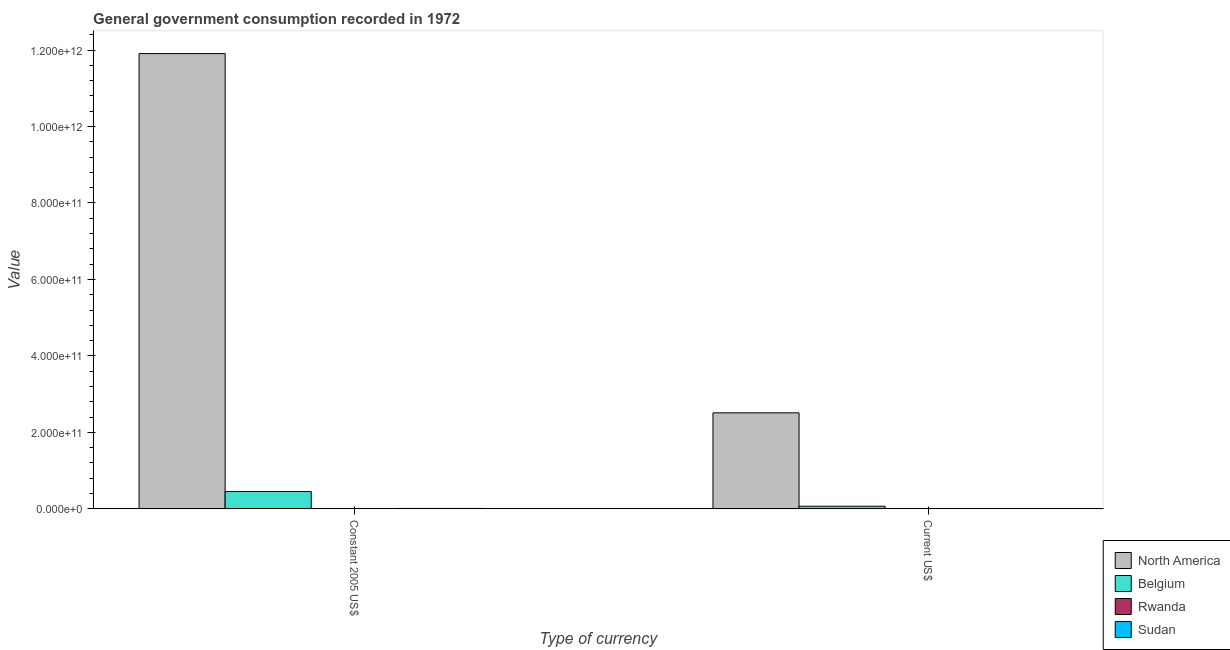How many different coloured bars are there?
Make the answer very short. 4. How many groups of bars are there?
Provide a short and direct response. 2. Are the number of bars per tick equal to the number of legend labels?
Keep it short and to the point. Yes. How many bars are there on the 1st tick from the left?
Ensure brevity in your answer.  4. What is the label of the 1st group of bars from the left?
Offer a terse response. Constant 2005 US$. What is the value consumed in constant 2005 us$ in Belgium?
Provide a succinct answer. 4.53e+1. Across all countries, what is the maximum value consumed in current us$?
Your response must be concise. 2.51e+11. Across all countries, what is the minimum value consumed in current us$?
Your response must be concise. 2.64e+07. In which country was the value consumed in current us$ minimum?
Provide a short and direct response. Rwanda. What is the total value consumed in constant 2005 us$ in the graph?
Keep it short and to the point. 1.24e+12. What is the difference between the value consumed in current us$ in Rwanda and that in Belgium?
Provide a succinct answer. -6.76e+09. What is the difference between the value consumed in constant 2005 us$ in North America and the value consumed in current us$ in Rwanda?
Make the answer very short. 1.19e+12. What is the average value consumed in current us$ per country?
Your response must be concise. 6.46e+1. What is the difference between the value consumed in constant 2005 us$ and value consumed in current us$ in Rwanda?
Make the answer very short. 5.56e+07. In how many countries, is the value consumed in current us$ greater than 760000000000 ?
Give a very brief answer. 0. What is the ratio of the value consumed in current us$ in Sudan to that in North America?
Offer a very short reply. 0. In how many countries, is the value consumed in constant 2005 us$ greater than the average value consumed in constant 2005 us$ taken over all countries?
Offer a very short reply. 1. What does the 3rd bar from the left in Constant 2005 US$ represents?
Make the answer very short. Rwanda. What does the 4th bar from the right in Current US$ represents?
Provide a short and direct response. North America. How many bars are there?
Ensure brevity in your answer.  8. What is the difference between two consecutive major ticks on the Y-axis?
Provide a succinct answer. 2.00e+11. Are the values on the major ticks of Y-axis written in scientific E-notation?
Give a very brief answer. Yes. Does the graph contain grids?
Ensure brevity in your answer.  No. How many legend labels are there?
Provide a short and direct response. 4. What is the title of the graph?
Provide a short and direct response. General government consumption recorded in 1972. Does "St. Martin (French part)" appear as one of the legend labels in the graph?
Your answer should be compact. No. What is the label or title of the X-axis?
Provide a short and direct response. Type of currency. What is the label or title of the Y-axis?
Ensure brevity in your answer.  Value. What is the Value of North America in Constant 2005 US$?
Give a very brief answer. 1.19e+12. What is the Value in Belgium in Constant 2005 US$?
Ensure brevity in your answer.  4.53e+1. What is the Value in Rwanda in Constant 2005 US$?
Offer a terse response. 8.20e+07. What is the Value of Sudan in Constant 2005 US$?
Your response must be concise. 1.15e+09. What is the Value of North America in Current US$?
Make the answer very short. 2.51e+11. What is the Value in Belgium in Current US$?
Ensure brevity in your answer.  6.79e+09. What is the Value of Rwanda in Current US$?
Offer a very short reply. 2.64e+07. What is the Value in Sudan in Current US$?
Make the answer very short. 4.48e+08. Across all Type of currency, what is the maximum Value in North America?
Your answer should be very brief. 1.19e+12. Across all Type of currency, what is the maximum Value in Belgium?
Keep it short and to the point. 4.53e+1. Across all Type of currency, what is the maximum Value in Rwanda?
Keep it short and to the point. 8.20e+07. Across all Type of currency, what is the maximum Value of Sudan?
Your answer should be very brief. 1.15e+09. Across all Type of currency, what is the minimum Value in North America?
Give a very brief answer. 2.51e+11. Across all Type of currency, what is the minimum Value of Belgium?
Your response must be concise. 6.79e+09. Across all Type of currency, what is the minimum Value in Rwanda?
Offer a very short reply. 2.64e+07. Across all Type of currency, what is the minimum Value in Sudan?
Offer a terse response. 4.48e+08. What is the total Value of North America in the graph?
Provide a short and direct response. 1.44e+12. What is the total Value of Belgium in the graph?
Your response must be concise. 5.21e+1. What is the total Value of Rwanda in the graph?
Ensure brevity in your answer.  1.08e+08. What is the total Value of Sudan in the graph?
Ensure brevity in your answer.  1.59e+09. What is the difference between the Value of North America in Constant 2005 US$ and that in Current US$?
Keep it short and to the point. 9.40e+11. What is the difference between the Value in Belgium in Constant 2005 US$ and that in Current US$?
Give a very brief answer. 3.85e+1. What is the difference between the Value in Rwanda in Constant 2005 US$ and that in Current US$?
Make the answer very short. 5.56e+07. What is the difference between the Value in Sudan in Constant 2005 US$ and that in Current US$?
Give a very brief answer. 6.98e+08. What is the difference between the Value of North America in Constant 2005 US$ and the Value of Belgium in Current US$?
Your answer should be very brief. 1.18e+12. What is the difference between the Value in North America in Constant 2005 US$ and the Value in Rwanda in Current US$?
Make the answer very short. 1.19e+12. What is the difference between the Value in North America in Constant 2005 US$ and the Value in Sudan in Current US$?
Make the answer very short. 1.19e+12. What is the difference between the Value in Belgium in Constant 2005 US$ and the Value in Rwanda in Current US$?
Ensure brevity in your answer.  4.53e+1. What is the difference between the Value of Belgium in Constant 2005 US$ and the Value of Sudan in Current US$?
Give a very brief answer. 4.49e+1. What is the difference between the Value of Rwanda in Constant 2005 US$ and the Value of Sudan in Current US$?
Offer a terse response. -3.66e+08. What is the average Value in North America per Type of currency?
Offer a very short reply. 7.21e+11. What is the average Value in Belgium per Type of currency?
Give a very brief answer. 2.60e+1. What is the average Value of Rwanda per Type of currency?
Provide a short and direct response. 5.42e+07. What is the average Value in Sudan per Type of currency?
Make the answer very short. 7.97e+08. What is the difference between the Value in North America and Value in Belgium in Constant 2005 US$?
Give a very brief answer. 1.15e+12. What is the difference between the Value of North America and Value of Rwanda in Constant 2005 US$?
Your answer should be compact. 1.19e+12. What is the difference between the Value in North America and Value in Sudan in Constant 2005 US$?
Make the answer very short. 1.19e+12. What is the difference between the Value in Belgium and Value in Rwanda in Constant 2005 US$?
Provide a succinct answer. 4.52e+1. What is the difference between the Value of Belgium and Value of Sudan in Constant 2005 US$?
Ensure brevity in your answer.  4.42e+1. What is the difference between the Value of Rwanda and Value of Sudan in Constant 2005 US$?
Offer a terse response. -1.06e+09. What is the difference between the Value in North America and Value in Belgium in Current US$?
Offer a terse response. 2.44e+11. What is the difference between the Value of North America and Value of Rwanda in Current US$?
Provide a succinct answer. 2.51e+11. What is the difference between the Value of North America and Value of Sudan in Current US$?
Make the answer very short. 2.51e+11. What is the difference between the Value of Belgium and Value of Rwanda in Current US$?
Offer a terse response. 6.76e+09. What is the difference between the Value of Belgium and Value of Sudan in Current US$?
Your answer should be compact. 6.34e+09. What is the difference between the Value in Rwanda and Value in Sudan in Current US$?
Make the answer very short. -4.21e+08. What is the ratio of the Value of North America in Constant 2005 US$ to that in Current US$?
Offer a very short reply. 4.74. What is the ratio of the Value of Belgium in Constant 2005 US$ to that in Current US$?
Offer a very short reply. 6.67. What is the ratio of the Value of Rwanda in Constant 2005 US$ to that in Current US$?
Keep it short and to the point. 3.11. What is the ratio of the Value of Sudan in Constant 2005 US$ to that in Current US$?
Your answer should be very brief. 2.56. What is the difference between the highest and the second highest Value of North America?
Offer a very short reply. 9.40e+11. What is the difference between the highest and the second highest Value in Belgium?
Your response must be concise. 3.85e+1. What is the difference between the highest and the second highest Value in Rwanda?
Ensure brevity in your answer.  5.56e+07. What is the difference between the highest and the second highest Value of Sudan?
Keep it short and to the point. 6.98e+08. What is the difference between the highest and the lowest Value of North America?
Your response must be concise. 9.40e+11. What is the difference between the highest and the lowest Value of Belgium?
Offer a very short reply. 3.85e+1. What is the difference between the highest and the lowest Value of Rwanda?
Offer a terse response. 5.56e+07. What is the difference between the highest and the lowest Value in Sudan?
Ensure brevity in your answer.  6.98e+08. 